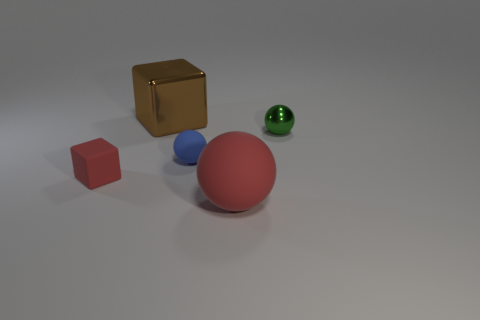Can you describe the lighting and shadows in the scene? The lighting in the scene appears soft and diffuse, creating gentle shadows. The direction of the light is from above, given the positioning of the shadows, which extend towards the viewer, suggesting an overhead light source that softly illuminates the entire scene without harsh contrasts. 